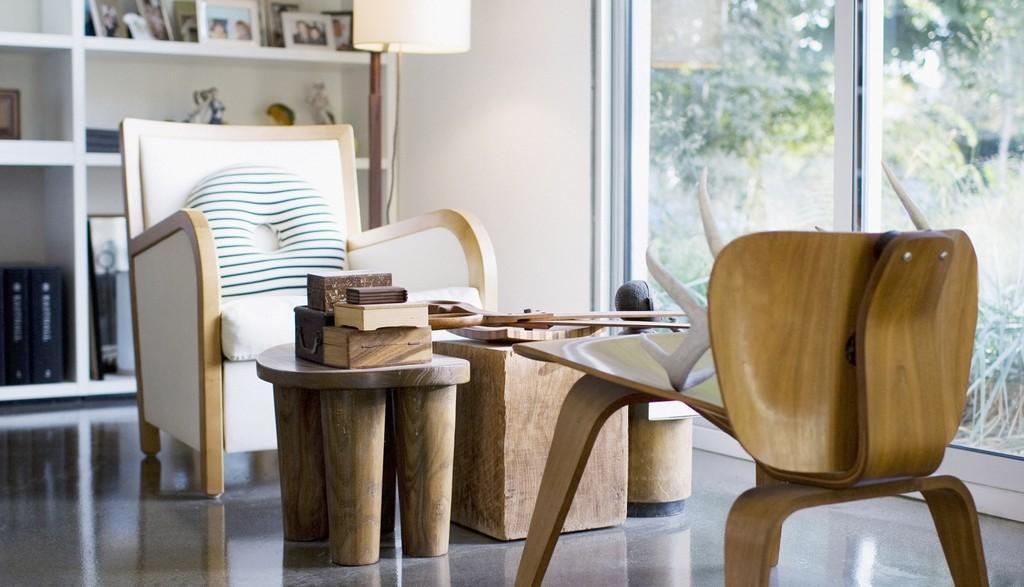Can you describe this image briefly? On the right there is an object on a chair. In the background there is a chair,wooden boxes on a stool,long scissor and other objects on a platform and there are photo frames,sculptures,boxes and other objects are on the racks and this is wall and glass doors. Through the glass doors we can see trees. 